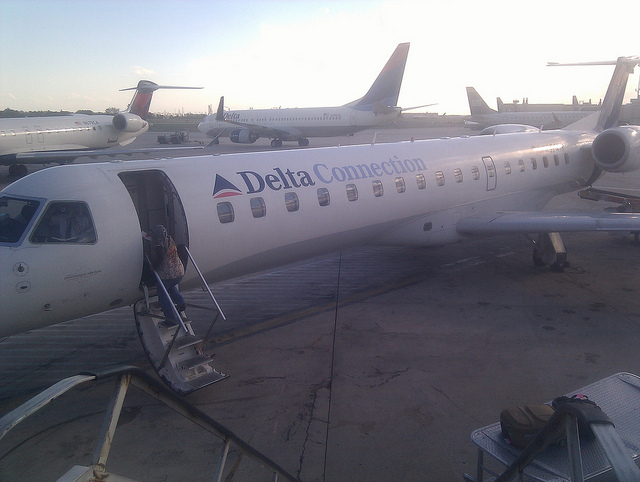Please transcribe the text information in this image. Delta Connection 